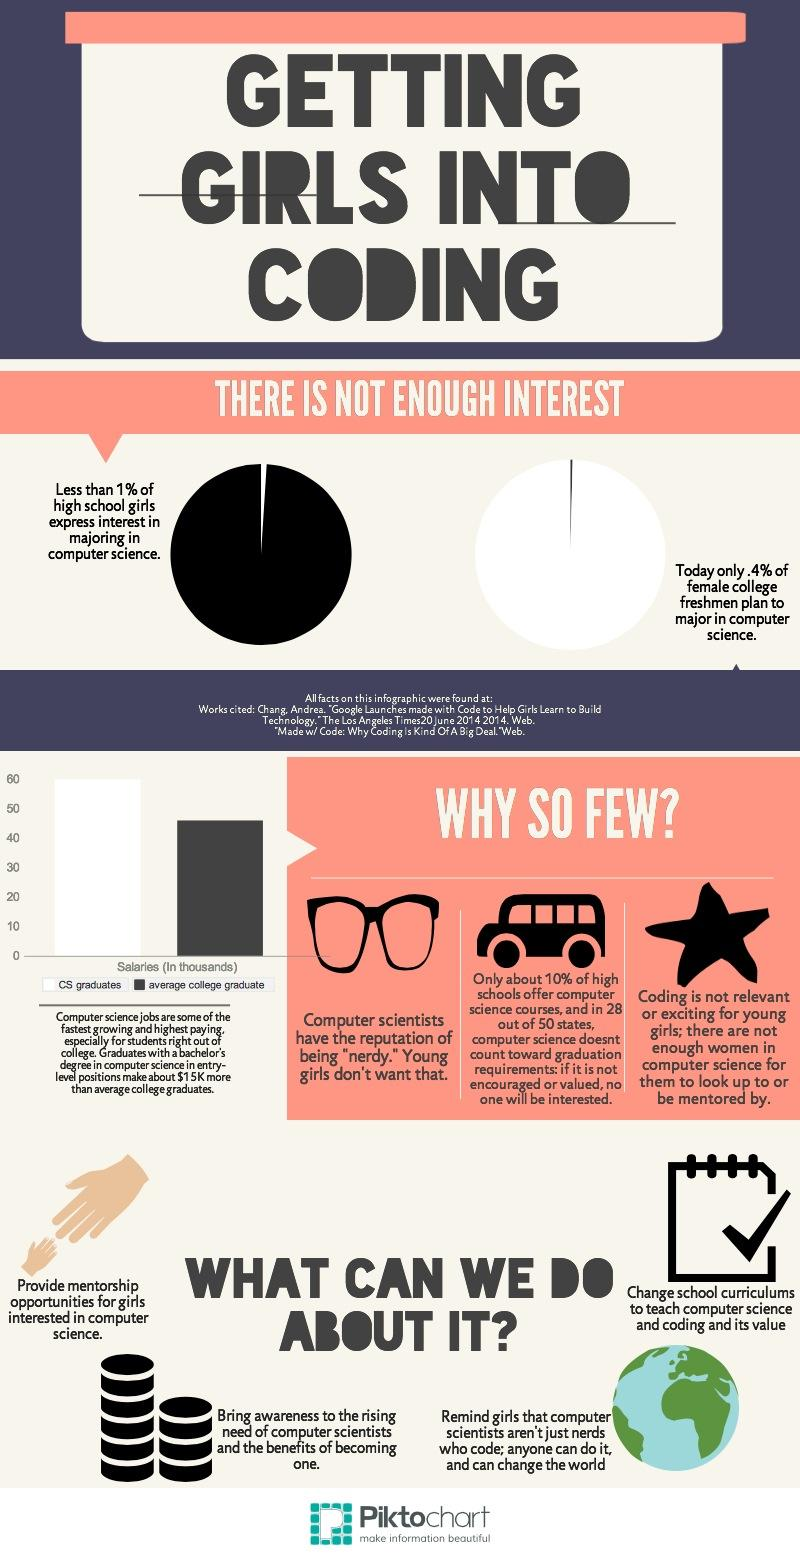Specify some key components in this picture. Nine out of ten high schools are not offering computer science courses. Out of the 50 states, 22 states require computer science to be counted towards graduation requirements. 